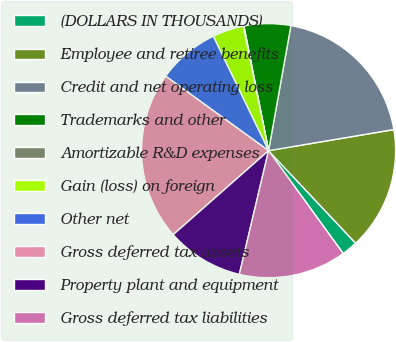<chart> <loc_0><loc_0><loc_500><loc_500><pie_chart><fcel>(DOLLARS IN THOUSANDS)<fcel>Employee and retiree benefits<fcel>Credit and net operating loss<fcel>Trademarks and other<fcel>Amortizable R&D expenses<fcel>Gain (loss) on foreign<fcel>Other net<fcel>Gross deferred tax assets<fcel>Property plant and equipment<fcel>Gross deferred tax liabilities<nl><fcel>2.03%<fcel>15.64%<fcel>19.53%<fcel>5.92%<fcel>0.09%<fcel>3.97%<fcel>7.86%<fcel>21.47%<fcel>9.81%<fcel>13.69%<nl></chart> 